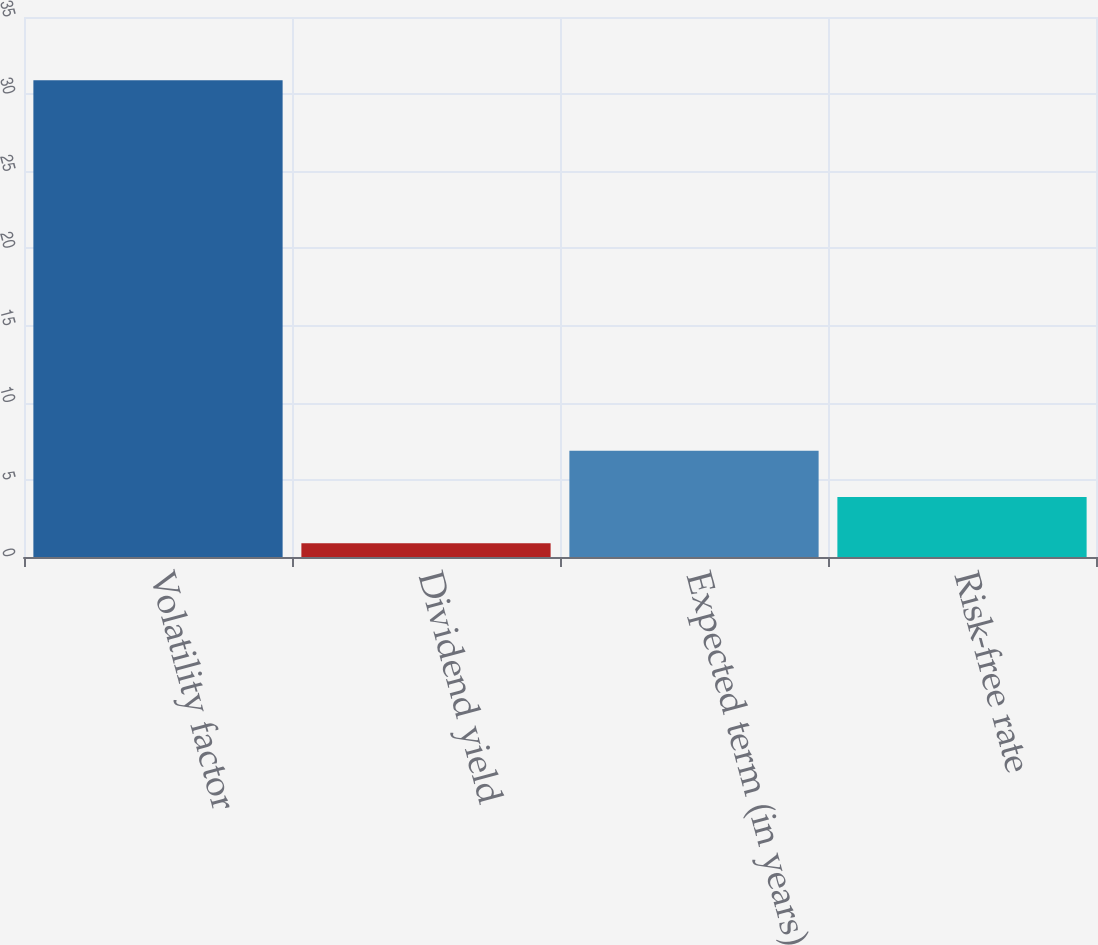<chart> <loc_0><loc_0><loc_500><loc_500><bar_chart><fcel>Volatility factor<fcel>Dividend yield<fcel>Expected term (in years)<fcel>Risk-free rate<nl><fcel>30.9<fcel>0.89<fcel>6.89<fcel>3.89<nl></chart> 